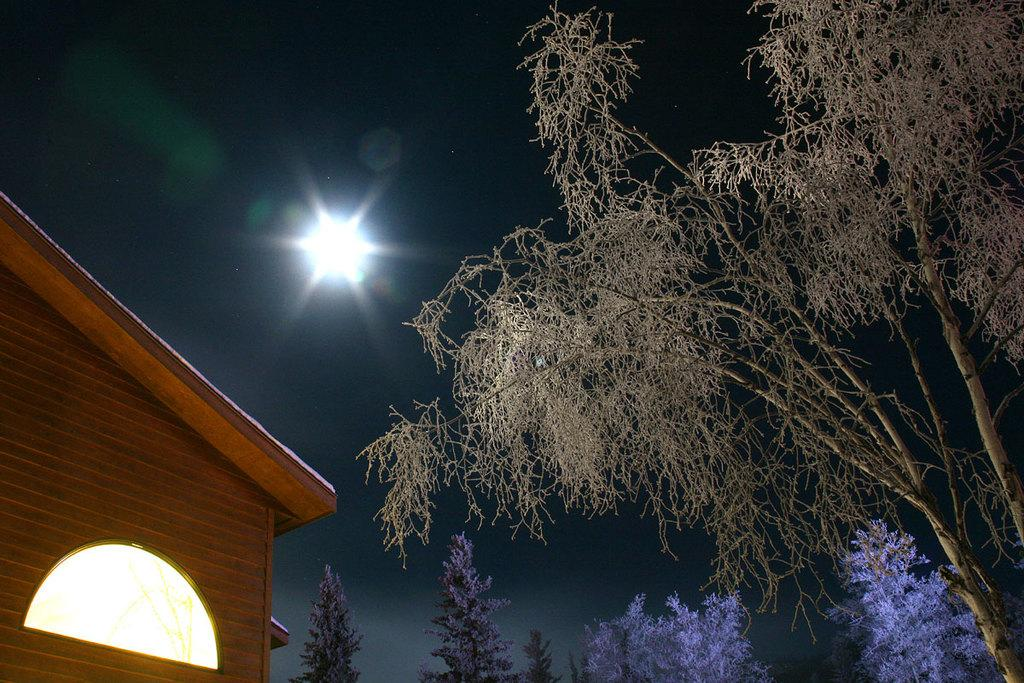What type of vegetation is present in the image? There is a group of trees in the image. Where is the house located in the image? The house is on the left side of the image. What can be seen in the sky in the image? There is a light visible in the sky. What type of calendar is hanging on the trees in the image? There is no calendar present in the image; it features a group of trees and a house. What kind of grain can be seen growing near the house in the image? There is no grain present in the image; it only shows a house and a group of trees. 